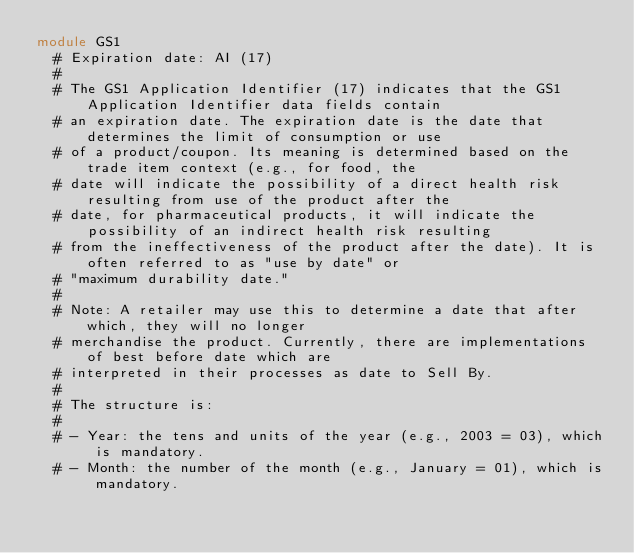Convert code to text. <code><loc_0><loc_0><loc_500><loc_500><_Ruby_>module GS1
  # Expiration date: AI (17)
  #
  # The GS1 Application Identifier (17) indicates that the GS1 Application Identifier data fields contain
  # an expiration date. The expiration date is the date that determines the limit of consumption or use
  # of a product/coupon. Its meaning is determined based on the trade item context (e.g., for food, the
  # date will indicate the possibility of a direct health risk resulting from use of the product after the
  # date, for pharmaceutical products, it will indicate the possibility of an indirect health risk resulting
  # from the ineffectiveness of the product after the date). It is often referred to as "use by date" or
  # "maximum durability date."
  #
  # Note: A retailer may use this to determine a date that after which, they will no longer
  # merchandise the product. Currently, there are implementations of best before date which are
  # interpreted in their processes as date to Sell By.
  #
  # The structure is:
  #
  # - Year: the tens and units of the year (e.g., 2003 = 03), which is mandatory.
  # - Month: the number of the month (e.g., January = 01), which is mandatory.</code> 